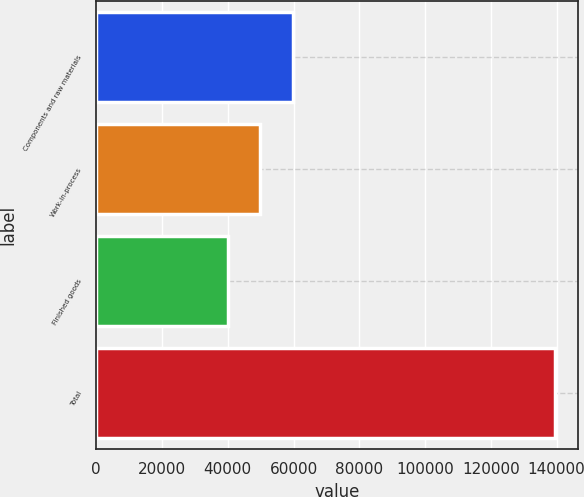Convert chart to OTSL. <chart><loc_0><loc_0><loc_500><loc_500><bar_chart><fcel>Components and raw materials<fcel>Work-in-process<fcel>Finished goods<fcel>Total<nl><fcel>59877.2<fcel>49909.6<fcel>39942<fcel>139618<nl></chart> 